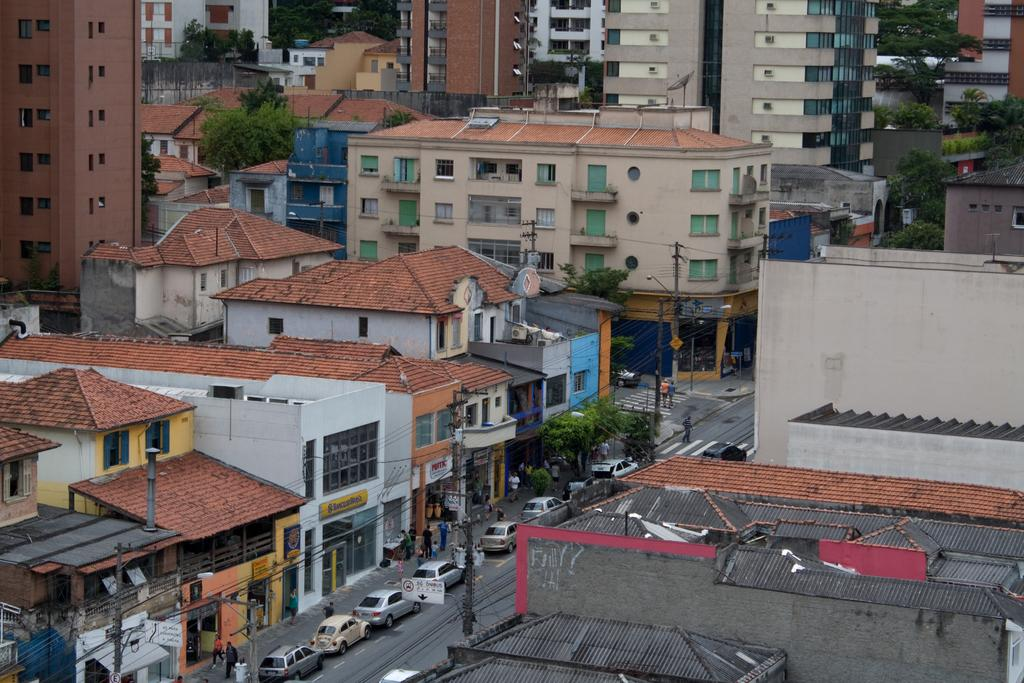What types of objects can be seen in the image? There are vehicles, poles, and cables in the image. Are there any living beings present in the image? Yes, there are people in the image. What can be seen in the background of the image? There are trees and buildings in the background of the image. Can you describe the squirrel that is joining the people in the image? There is no squirrel present in the image, nor is there any indication of a squirrel joining the people. 